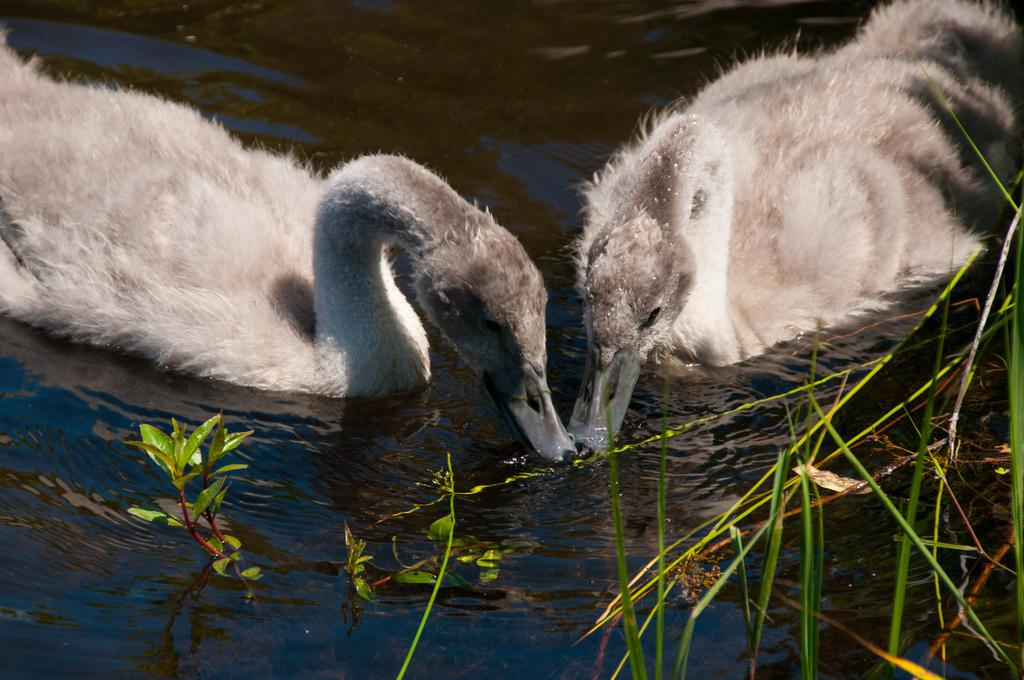What type of animals are in the image? There are swans in the image. What color are the swans? The swans are white in color. Where are the swans located? The swans are in the water. What can be seen in the foreground of the image? There are water plants in the foreground of the image. What type of seed is being planted by the swans in the image? There is no seed being planted by the swans in the image; they are simply swimming in the water. 